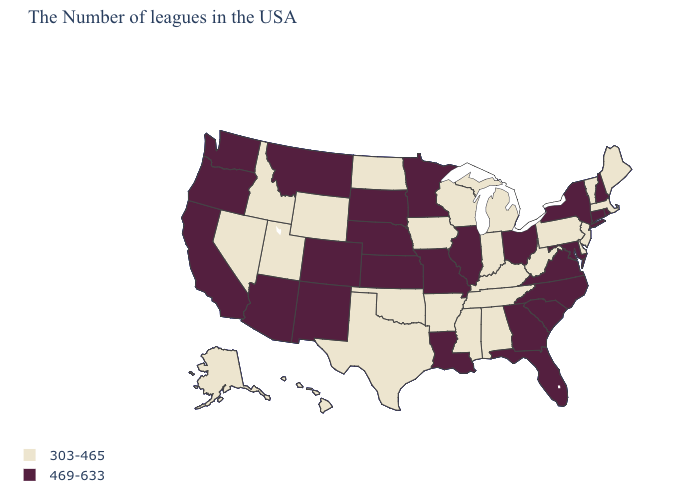What is the value of Utah?
Quick response, please. 303-465. What is the value of New Jersey?
Concise answer only. 303-465. What is the value of South Carolina?
Short answer required. 469-633. Which states have the lowest value in the USA?
Quick response, please. Maine, Massachusetts, Vermont, New Jersey, Delaware, Pennsylvania, West Virginia, Michigan, Kentucky, Indiana, Alabama, Tennessee, Wisconsin, Mississippi, Arkansas, Iowa, Oklahoma, Texas, North Dakota, Wyoming, Utah, Idaho, Nevada, Alaska, Hawaii. What is the value of South Dakota?
Keep it brief. 469-633. Name the states that have a value in the range 303-465?
Be succinct. Maine, Massachusetts, Vermont, New Jersey, Delaware, Pennsylvania, West Virginia, Michigan, Kentucky, Indiana, Alabama, Tennessee, Wisconsin, Mississippi, Arkansas, Iowa, Oklahoma, Texas, North Dakota, Wyoming, Utah, Idaho, Nevada, Alaska, Hawaii. Does Delaware have a lower value than Wisconsin?
Concise answer only. No. What is the value of Alaska?
Concise answer only. 303-465. What is the highest value in states that border Kansas?
Quick response, please. 469-633. What is the value of Ohio?
Answer briefly. 469-633. What is the highest value in the USA?
Be succinct. 469-633. Name the states that have a value in the range 303-465?
Answer briefly. Maine, Massachusetts, Vermont, New Jersey, Delaware, Pennsylvania, West Virginia, Michigan, Kentucky, Indiana, Alabama, Tennessee, Wisconsin, Mississippi, Arkansas, Iowa, Oklahoma, Texas, North Dakota, Wyoming, Utah, Idaho, Nevada, Alaska, Hawaii. Name the states that have a value in the range 469-633?
Concise answer only. Rhode Island, New Hampshire, Connecticut, New York, Maryland, Virginia, North Carolina, South Carolina, Ohio, Florida, Georgia, Illinois, Louisiana, Missouri, Minnesota, Kansas, Nebraska, South Dakota, Colorado, New Mexico, Montana, Arizona, California, Washington, Oregon. Does Indiana have the lowest value in the USA?
Answer briefly. Yes. Among the states that border South Dakota , which have the lowest value?
Be succinct. Iowa, North Dakota, Wyoming. 